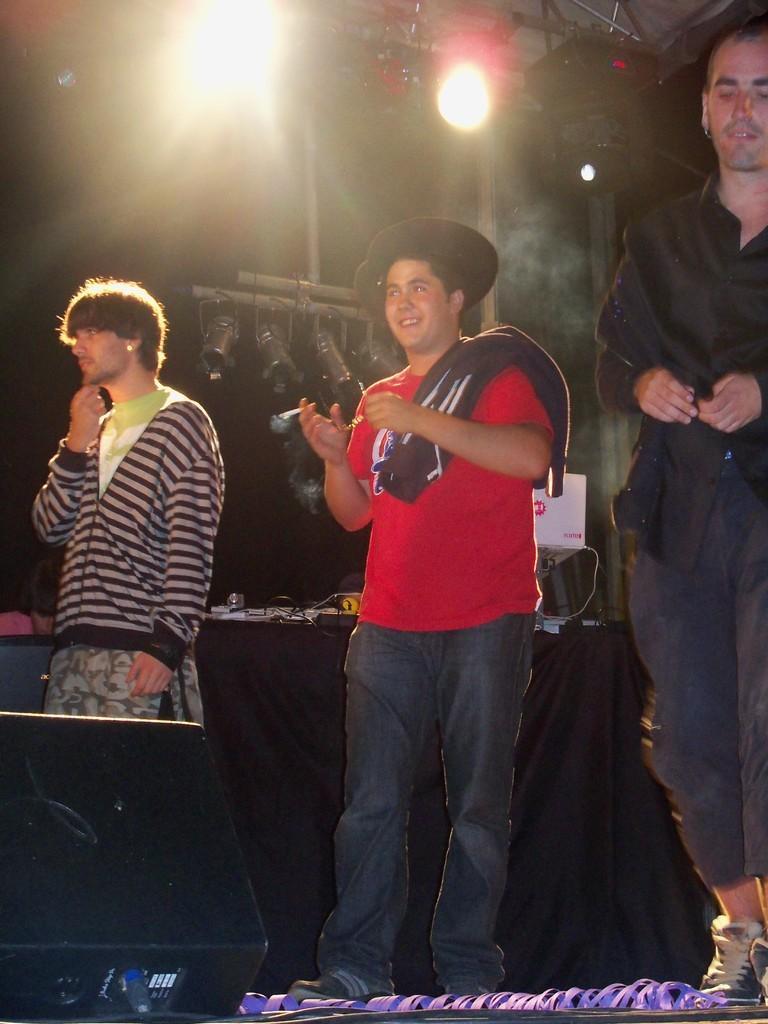Please provide a concise description of this image. In the center of the image a man is standing and wearing a cap. On the left and right side of the image two mans are standing. In the background of the image we can see a lights, roof, pole, cloth, board are present. At the bottom of the image ground is there. 